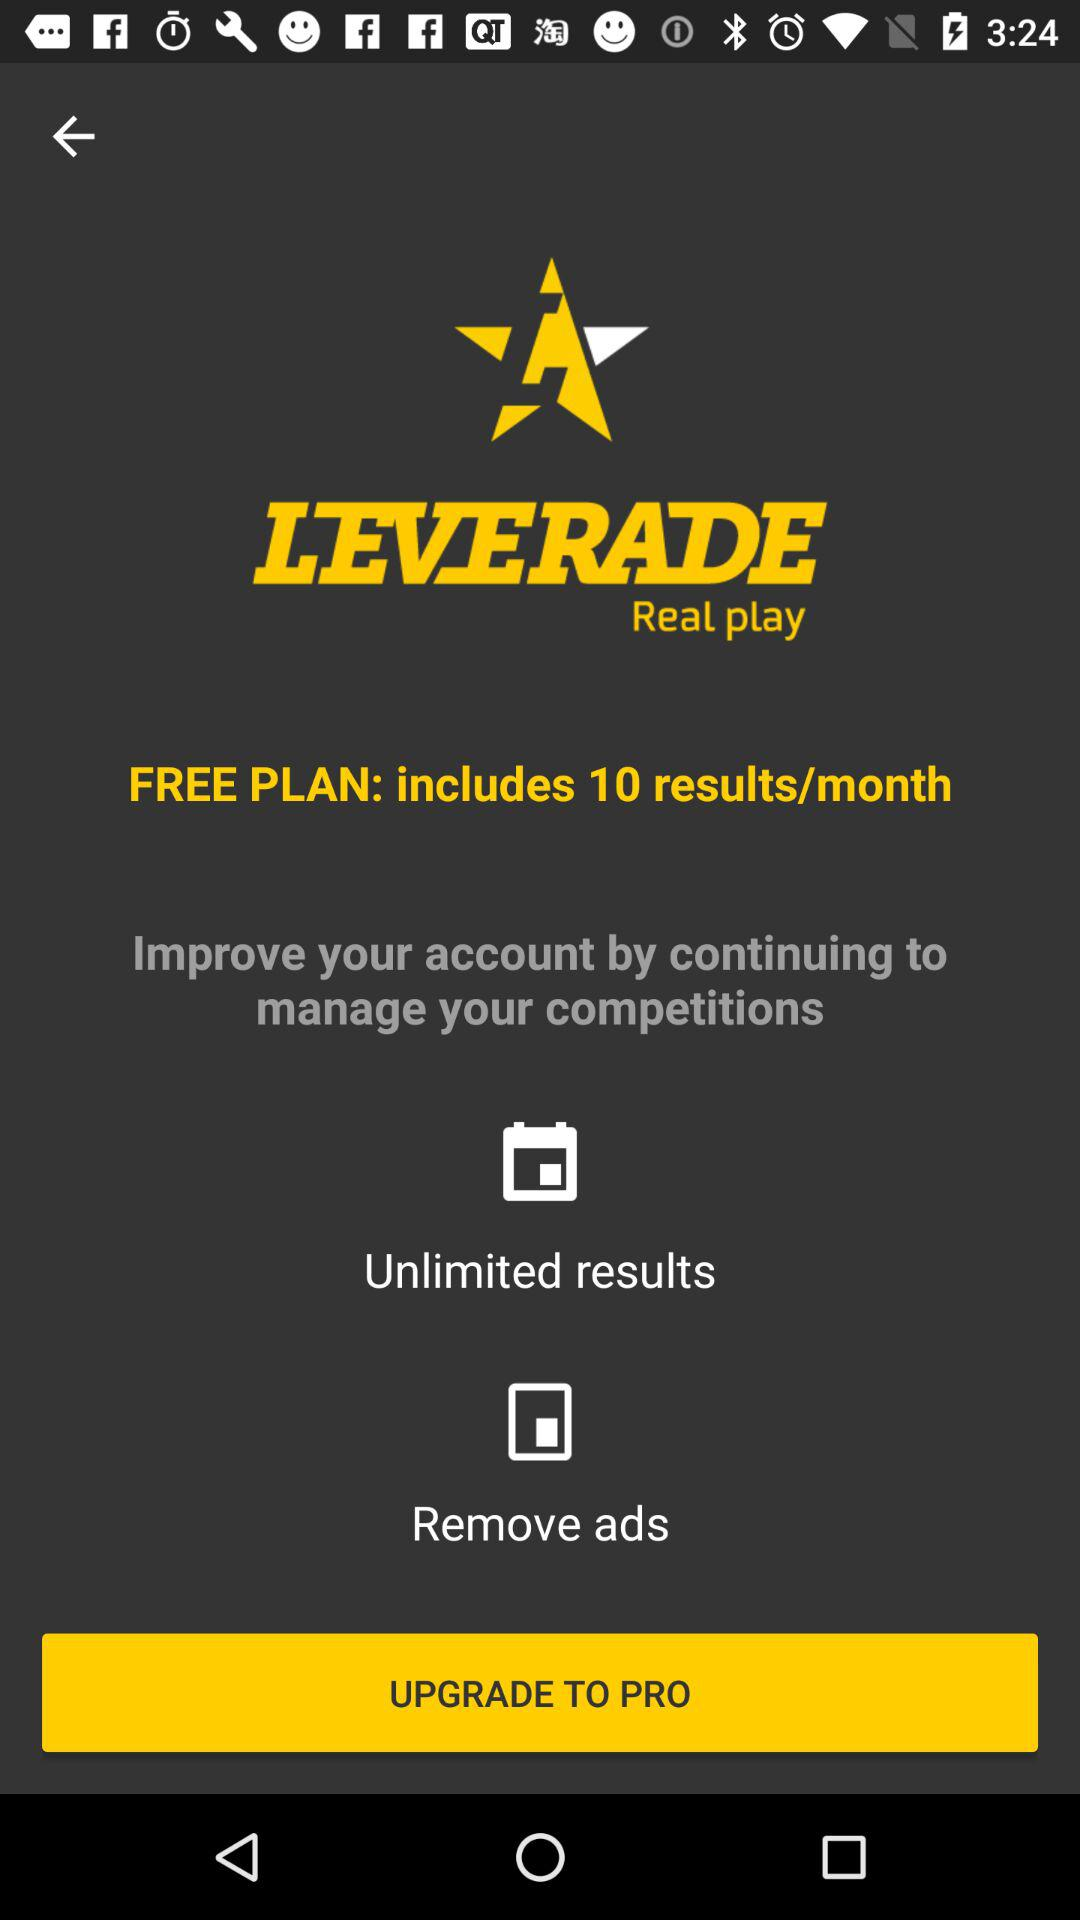What is the name of the application? The name of the application is "LEVERADE". 